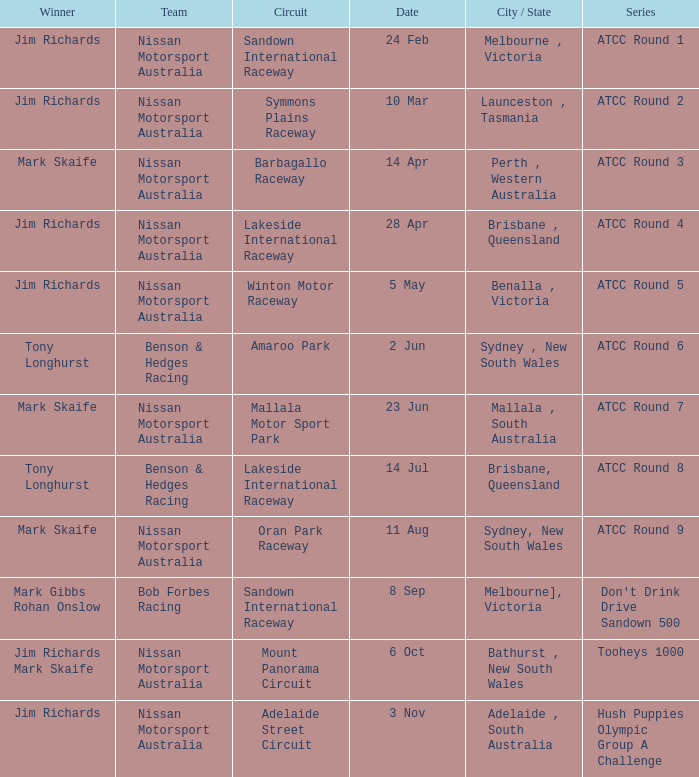What is the Circuit in the ATCC Round 1 Series with Winner Jim Richards? Sandown International Raceway. 